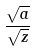<formula> <loc_0><loc_0><loc_500><loc_500>\frac { \sqrt { a } } { \sqrt { z } }</formula> 